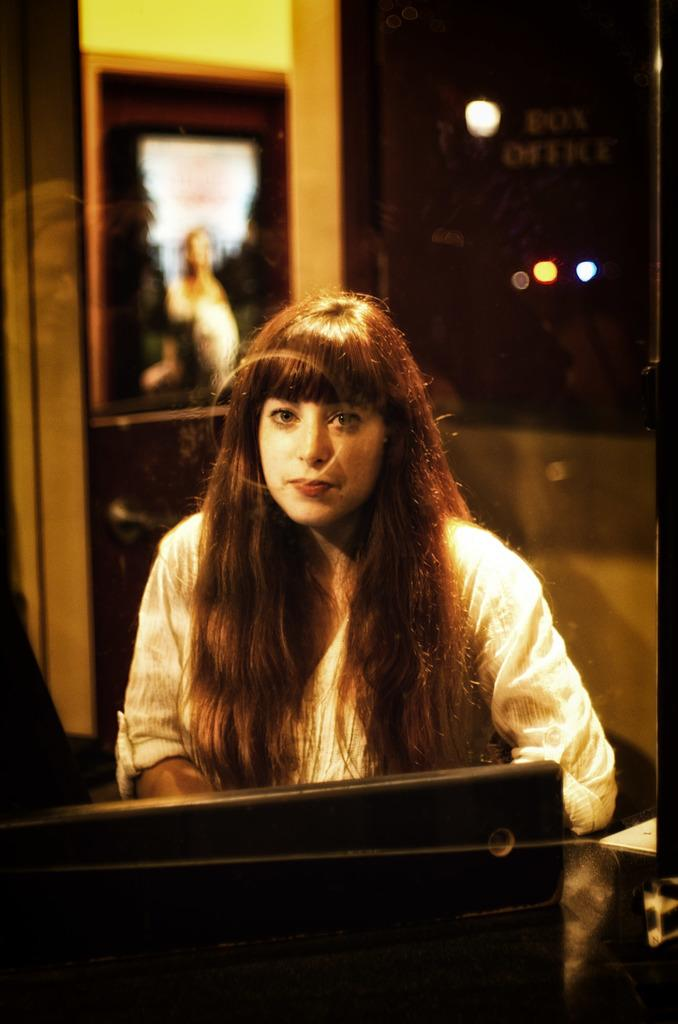What is the main subject of the image? There is a woman sitting in the center of the image. What is located in front of the woman? There is an object in front of the woman. What color is the object? The object is black in color. Can you describe the background of the image? The background of the image is blurry. What type of match is the woman holding in the image? There is no match present in the image. Can you describe the rose that is next to the woman in the image? There is no rose present in the image. 